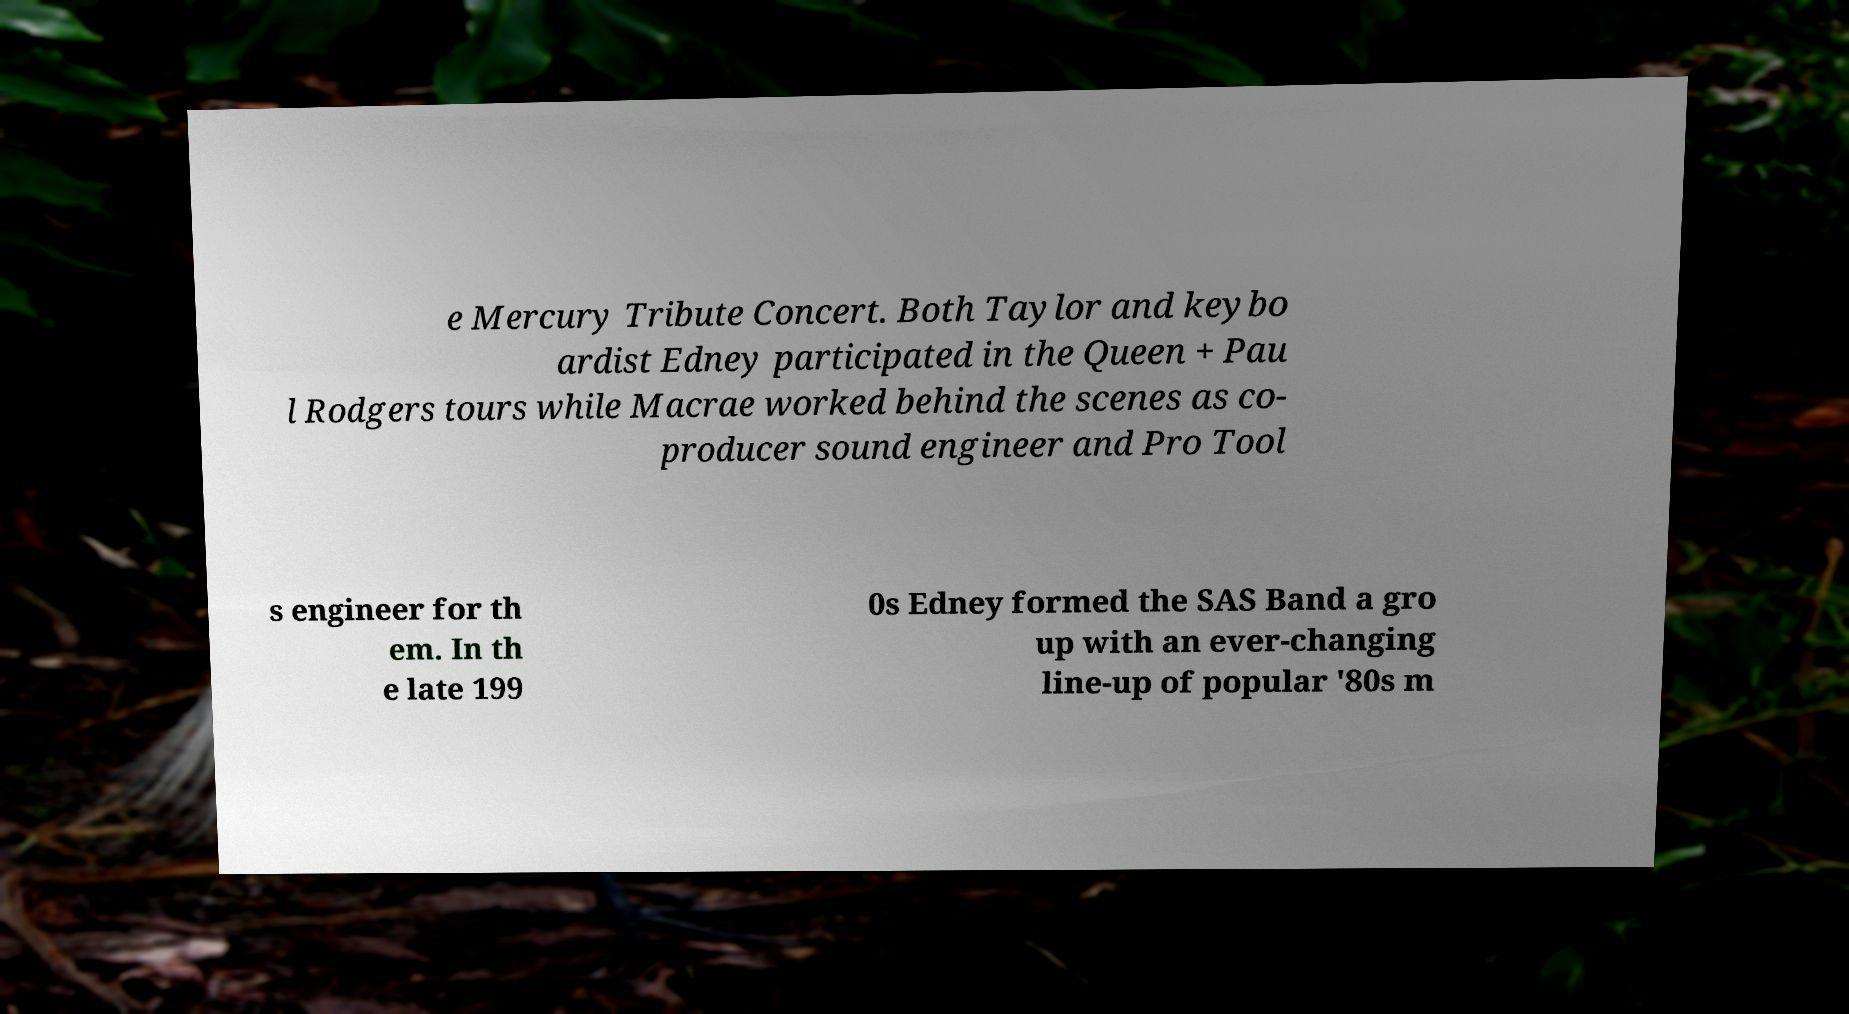I need the written content from this picture converted into text. Can you do that? e Mercury Tribute Concert. Both Taylor and keybo ardist Edney participated in the Queen + Pau l Rodgers tours while Macrae worked behind the scenes as co- producer sound engineer and Pro Tool s engineer for th em. In th e late 199 0s Edney formed the SAS Band a gro up with an ever-changing line-up of popular '80s m 